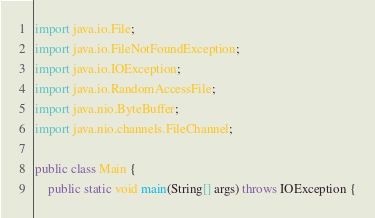<code> <loc_0><loc_0><loc_500><loc_500><_Java_>import java.io.File;
import java.io.FileNotFoundException;
import java.io.IOException;
import java.io.RandomAccessFile;
import java.nio.ByteBuffer;
import java.nio.channels.FileChannel;

public class Main {
    public static void main(String[] args) throws IOException {</code> 